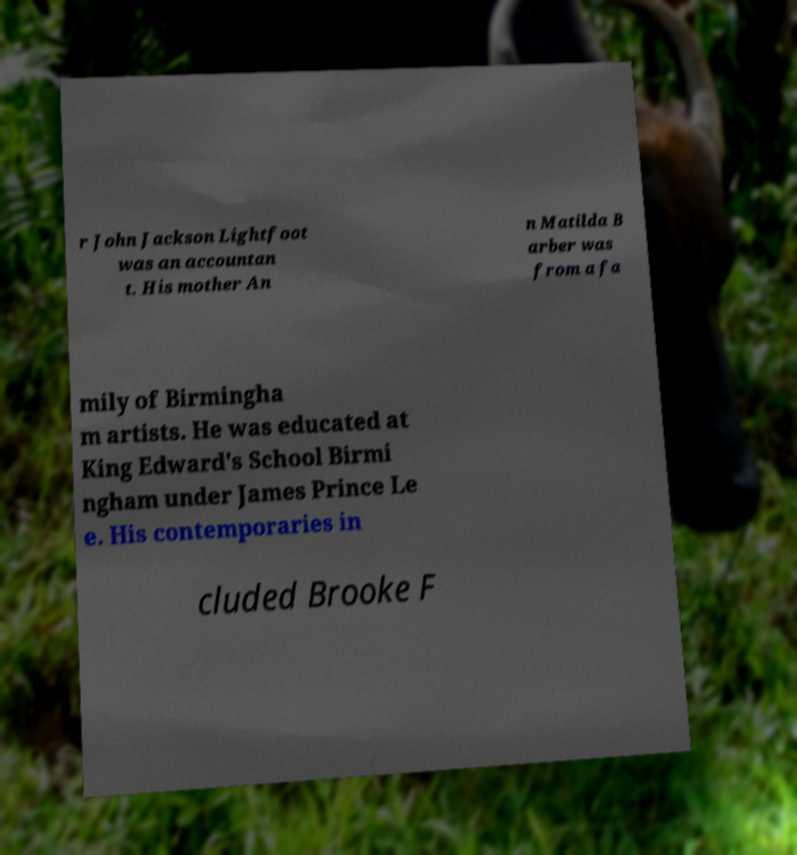There's text embedded in this image that I need extracted. Can you transcribe it verbatim? r John Jackson Lightfoot was an accountan t. His mother An n Matilda B arber was from a fa mily of Birmingha m artists. He was educated at King Edward's School Birmi ngham under James Prince Le e. His contemporaries in cluded Brooke F 